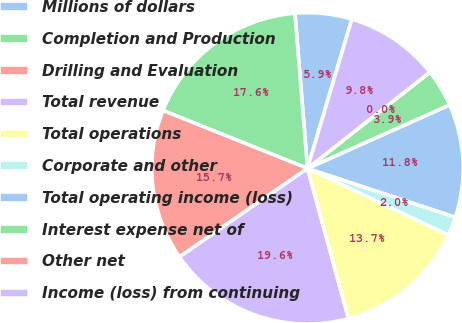Convert chart to OTSL. <chart><loc_0><loc_0><loc_500><loc_500><pie_chart><fcel>Millions of dollars<fcel>Completion and Production<fcel>Drilling and Evaluation<fcel>Total revenue<fcel>Total operations<fcel>Corporate and other<fcel>Total operating income (loss)<fcel>Interest expense net of<fcel>Other net<fcel>Income (loss) from continuing<nl><fcel>5.88%<fcel>17.65%<fcel>15.69%<fcel>19.61%<fcel>13.73%<fcel>1.96%<fcel>11.76%<fcel>3.92%<fcel>0.0%<fcel>9.8%<nl></chart> 